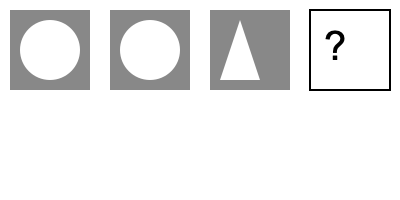Which symbol best completes the sequence of transformation and renewal? 1. Analyze the sequence of symbols:
   - First symbol: A dark square with a white circle inside
   - Second symbol: Similar to the first, representing continuity
   - Third symbol: A dark square with a white triangle inside, indicating change

2. Observe the pattern of transformation:
   - The background (square) remains constant
   - The inner shape changes from circle to triangle

3. Consider the concept of renewal:
   - Circles represent cycles or repetition
   - Triangles often symbolize growth or progress
   - The next logical step in renewal would be completion or wholeness

4. Interpret the symbols in context of personal transformation:
   - Circle: Initial state, repetitive patterns
   - Triangle: Growth, progress, overcoming challenges
   - Next step: Achieving wholeness or integration

5. Conclude that the most fitting symbol to complete the sequence would be a full white square, representing:
   - Complete transformation
   - Integration of all aspects
   - A blank slate or new beginning

This progression aligns with the journey of personal growth and renewal, reflecting the process of rebuilding one's life and finding inner peace.
Answer: A white square 